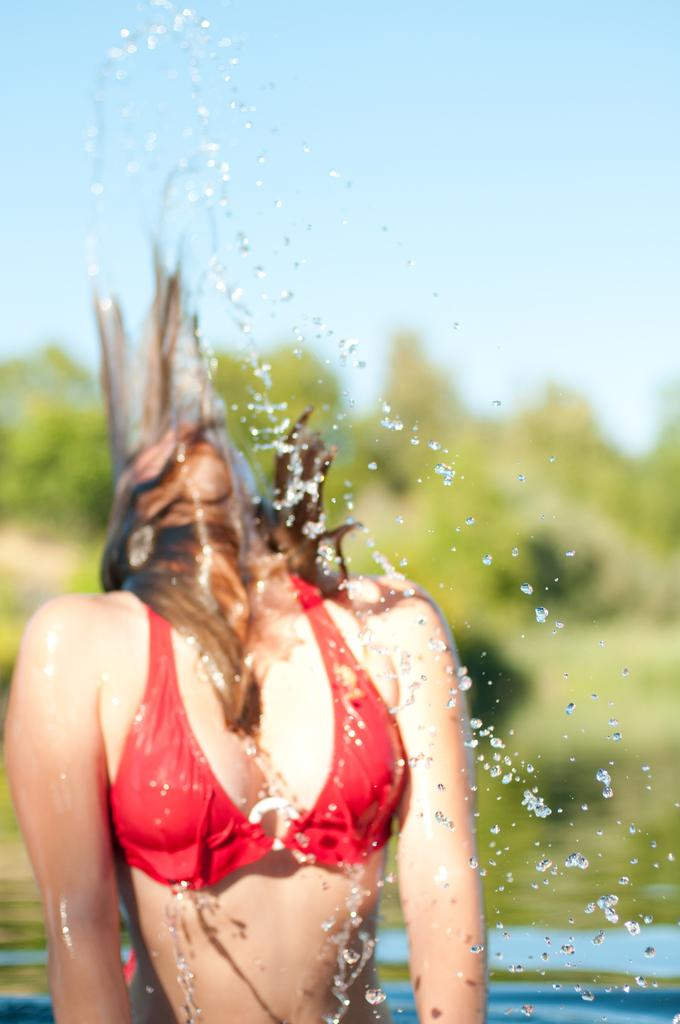Who is present in the image? There is a woman in the image. What can be seen on the woman in the image? There are drops of water in the image. What is visible in the background of the image? There are trees and the sky visible in the background of the image. What is the condition of the sky in the image? The sky appears to be cloudy in the image. What is the purpose of the poison in the image? There is no poison present in the image, so it cannot be determined what its purpose might be. 